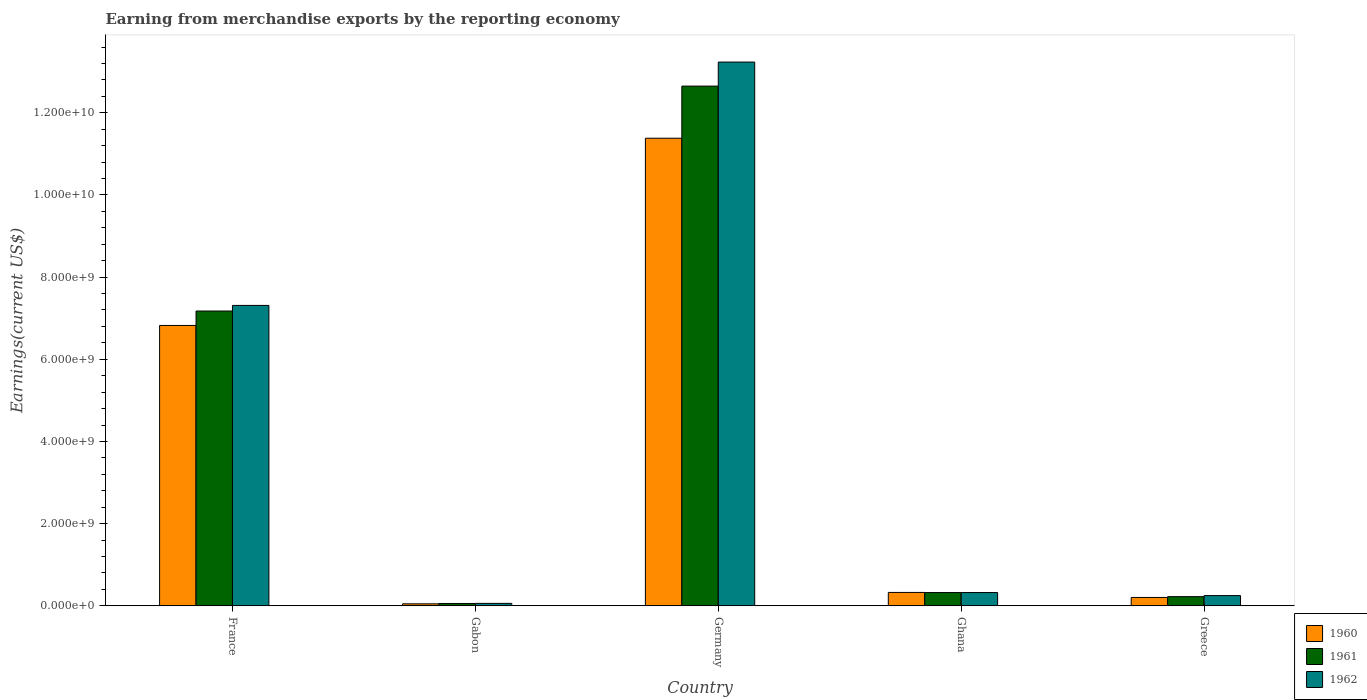How many groups of bars are there?
Provide a short and direct response. 5. How many bars are there on the 4th tick from the left?
Your response must be concise. 3. In how many cases, is the number of bars for a given country not equal to the number of legend labels?
Provide a succinct answer. 0. What is the amount earned from merchandise exports in 1962 in Ghana?
Provide a succinct answer. 3.23e+08. Across all countries, what is the maximum amount earned from merchandise exports in 1962?
Ensure brevity in your answer.  1.32e+1. Across all countries, what is the minimum amount earned from merchandise exports in 1960?
Give a very brief answer. 4.78e+07. In which country was the amount earned from merchandise exports in 1962 minimum?
Provide a succinct answer. Gabon. What is the total amount earned from merchandise exports in 1962 in the graph?
Ensure brevity in your answer.  2.12e+1. What is the difference between the amount earned from merchandise exports in 1961 in France and that in Germany?
Give a very brief answer. -5.48e+09. What is the difference between the amount earned from merchandise exports in 1960 in Germany and the amount earned from merchandise exports in 1961 in Greece?
Provide a succinct answer. 1.12e+1. What is the average amount earned from merchandise exports in 1962 per country?
Your answer should be compact. 4.24e+09. What is the difference between the amount earned from merchandise exports of/in 1962 and amount earned from merchandise exports of/in 1960 in Gabon?
Your answer should be compact. 1.08e+07. What is the ratio of the amount earned from merchandise exports in 1960 in France to that in Gabon?
Offer a terse response. 142.76. What is the difference between the highest and the second highest amount earned from merchandise exports in 1960?
Ensure brevity in your answer.  1.11e+1. What is the difference between the highest and the lowest amount earned from merchandise exports in 1960?
Make the answer very short. 1.13e+1. In how many countries, is the amount earned from merchandise exports in 1962 greater than the average amount earned from merchandise exports in 1962 taken over all countries?
Give a very brief answer. 2. Is the sum of the amount earned from merchandise exports in 1960 in Gabon and Ghana greater than the maximum amount earned from merchandise exports in 1961 across all countries?
Make the answer very short. No. Is it the case that in every country, the sum of the amount earned from merchandise exports in 1962 and amount earned from merchandise exports in 1961 is greater than the amount earned from merchandise exports in 1960?
Offer a very short reply. Yes. Are all the bars in the graph horizontal?
Your response must be concise. No. What is the difference between two consecutive major ticks on the Y-axis?
Give a very brief answer. 2.00e+09. Are the values on the major ticks of Y-axis written in scientific E-notation?
Make the answer very short. Yes. How are the legend labels stacked?
Make the answer very short. Vertical. What is the title of the graph?
Your answer should be very brief. Earning from merchandise exports by the reporting economy. What is the label or title of the X-axis?
Ensure brevity in your answer.  Country. What is the label or title of the Y-axis?
Your response must be concise. Earnings(current US$). What is the Earnings(current US$) in 1960 in France?
Offer a very short reply. 6.82e+09. What is the Earnings(current US$) in 1961 in France?
Give a very brief answer. 7.17e+09. What is the Earnings(current US$) of 1962 in France?
Provide a short and direct response. 7.31e+09. What is the Earnings(current US$) of 1960 in Gabon?
Offer a terse response. 4.78e+07. What is the Earnings(current US$) in 1961 in Gabon?
Your answer should be compact. 5.52e+07. What is the Earnings(current US$) in 1962 in Gabon?
Give a very brief answer. 5.86e+07. What is the Earnings(current US$) in 1960 in Germany?
Offer a terse response. 1.14e+1. What is the Earnings(current US$) of 1961 in Germany?
Keep it short and to the point. 1.26e+1. What is the Earnings(current US$) of 1962 in Germany?
Provide a succinct answer. 1.32e+1. What is the Earnings(current US$) in 1960 in Ghana?
Provide a short and direct response. 3.25e+08. What is the Earnings(current US$) of 1961 in Ghana?
Your answer should be compact. 3.22e+08. What is the Earnings(current US$) in 1962 in Ghana?
Offer a very short reply. 3.23e+08. What is the Earnings(current US$) of 1960 in Greece?
Provide a short and direct response. 2.03e+08. What is the Earnings(current US$) of 1961 in Greece?
Your answer should be compact. 2.22e+08. What is the Earnings(current US$) in 1962 in Greece?
Give a very brief answer. 2.48e+08. Across all countries, what is the maximum Earnings(current US$) of 1960?
Keep it short and to the point. 1.14e+1. Across all countries, what is the maximum Earnings(current US$) in 1961?
Your response must be concise. 1.26e+1. Across all countries, what is the maximum Earnings(current US$) in 1962?
Make the answer very short. 1.32e+1. Across all countries, what is the minimum Earnings(current US$) of 1960?
Offer a terse response. 4.78e+07. Across all countries, what is the minimum Earnings(current US$) in 1961?
Keep it short and to the point. 5.52e+07. Across all countries, what is the minimum Earnings(current US$) of 1962?
Offer a terse response. 5.86e+07. What is the total Earnings(current US$) in 1960 in the graph?
Offer a very short reply. 1.88e+1. What is the total Earnings(current US$) in 1961 in the graph?
Make the answer very short. 2.04e+1. What is the total Earnings(current US$) of 1962 in the graph?
Your answer should be compact. 2.12e+1. What is the difference between the Earnings(current US$) in 1960 in France and that in Gabon?
Offer a terse response. 6.78e+09. What is the difference between the Earnings(current US$) in 1961 in France and that in Gabon?
Offer a terse response. 7.12e+09. What is the difference between the Earnings(current US$) of 1962 in France and that in Gabon?
Your answer should be very brief. 7.25e+09. What is the difference between the Earnings(current US$) of 1960 in France and that in Germany?
Offer a terse response. -4.56e+09. What is the difference between the Earnings(current US$) of 1961 in France and that in Germany?
Provide a short and direct response. -5.48e+09. What is the difference between the Earnings(current US$) in 1962 in France and that in Germany?
Provide a succinct answer. -5.92e+09. What is the difference between the Earnings(current US$) in 1960 in France and that in Ghana?
Your response must be concise. 6.50e+09. What is the difference between the Earnings(current US$) of 1961 in France and that in Ghana?
Provide a succinct answer. 6.85e+09. What is the difference between the Earnings(current US$) in 1962 in France and that in Ghana?
Your response must be concise. 6.99e+09. What is the difference between the Earnings(current US$) of 1960 in France and that in Greece?
Provide a succinct answer. 6.62e+09. What is the difference between the Earnings(current US$) in 1961 in France and that in Greece?
Keep it short and to the point. 6.95e+09. What is the difference between the Earnings(current US$) of 1962 in France and that in Greece?
Provide a succinct answer. 7.06e+09. What is the difference between the Earnings(current US$) of 1960 in Gabon and that in Germany?
Make the answer very short. -1.13e+1. What is the difference between the Earnings(current US$) of 1961 in Gabon and that in Germany?
Offer a very short reply. -1.26e+1. What is the difference between the Earnings(current US$) in 1962 in Gabon and that in Germany?
Offer a very short reply. -1.32e+1. What is the difference between the Earnings(current US$) of 1960 in Gabon and that in Ghana?
Give a very brief answer. -2.77e+08. What is the difference between the Earnings(current US$) of 1961 in Gabon and that in Ghana?
Offer a terse response. -2.67e+08. What is the difference between the Earnings(current US$) in 1962 in Gabon and that in Ghana?
Your answer should be very brief. -2.64e+08. What is the difference between the Earnings(current US$) in 1960 in Gabon and that in Greece?
Keep it short and to the point. -1.55e+08. What is the difference between the Earnings(current US$) of 1961 in Gabon and that in Greece?
Provide a succinct answer. -1.67e+08. What is the difference between the Earnings(current US$) in 1962 in Gabon and that in Greece?
Keep it short and to the point. -1.90e+08. What is the difference between the Earnings(current US$) in 1960 in Germany and that in Ghana?
Keep it short and to the point. 1.11e+1. What is the difference between the Earnings(current US$) of 1961 in Germany and that in Ghana?
Provide a succinct answer. 1.23e+1. What is the difference between the Earnings(current US$) in 1962 in Germany and that in Ghana?
Offer a very short reply. 1.29e+1. What is the difference between the Earnings(current US$) of 1960 in Germany and that in Greece?
Your answer should be very brief. 1.12e+1. What is the difference between the Earnings(current US$) in 1961 in Germany and that in Greece?
Provide a short and direct response. 1.24e+1. What is the difference between the Earnings(current US$) of 1962 in Germany and that in Greece?
Provide a succinct answer. 1.30e+1. What is the difference between the Earnings(current US$) in 1960 in Ghana and that in Greece?
Provide a succinct answer. 1.22e+08. What is the difference between the Earnings(current US$) of 1961 in Ghana and that in Greece?
Make the answer very short. 9.98e+07. What is the difference between the Earnings(current US$) in 1962 in Ghana and that in Greece?
Offer a terse response. 7.43e+07. What is the difference between the Earnings(current US$) in 1960 in France and the Earnings(current US$) in 1961 in Gabon?
Make the answer very short. 6.77e+09. What is the difference between the Earnings(current US$) of 1960 in France and the Earnings(current US$) of 1962 in Gabon?
Provide a short and direct response. 6.77e+09. What is the difference between the Earnings(current US$) in 1961 in France and the Earnings(current US$) in 1962 in Gabon?
Offer a terse response. 7.12e+09. What is the difference between the Earnings(current US$) of 1960 in France and the Earnings(current US$) of 1961 in Germany?
Offer a very short reply. -5.83e+09. What is the difference between the Earnings(current US$) in 1960 in France and the Earnings(current US$) in 1962 in Germany?
Keep it short and to the point. -6.41e+09. What is the difference between the Earnings(current US$) of 1961 in France and the Earnings(current US$) of 1962 in Germany?
Your response must be concise. -6.06e+09. What is the difference between the Earnings(current US$) of 1960 in France and the Earnings(current US$) of 1961 in Ghana?
Provide a succinct answer. 6.50e+09. What is the difference between the Earnings(current US$) in 1960 in France and the Earnings(current US$) in 1962 in Ghana?
Offer a very short reply. 6.50e+09. What is the difference between the Earnings(current US$) of 1961 in France and the Earnings(current US$) of 1962 in Ghana?
Provide a short and direct response. 6.85e+09. What is the difference between the Earnings(current US$) of 1960 in France and the Earnings(current US$) of 1961 in Greece?
Your response must be concise. 6.60e+09. What is the difference between the Earnings(current US$) of 1960 in France and the Earnings(current US$) of 1962 in Greece?
Make the answer very short. 6.58e+09. What is the difference between the Earnings(current US$) of 1961 in France and the Earnings(current US$) of 1962 in Greece?
Your answer should be very brief. 6.93e+09. What is the difference between the Earnings(current US$) of 1960 in Gabon and the Earnings(current US$) of 1961 in Germany?
Offer a very short reply. -1.26e+1. What is the difference between the Earnings(current US$) in 1960 in Gabon and the Earnings(current US$) in 1962 in Germany?
Your response must be concise. -1.32e+1. What is the difference between the Earnings(current US$) in 1961 in Gabon and the Earnings(current US$) in 1962 in Germany?
Provide a short and direct response. -1.32e+1. What is the difference between the Earnings(current US$) of 1960 in Gabon and the Earnings(current US$) of 1961 in Ghana?
Offer a terse response. -2.74e+08. What is the difference between the Earnings(current US$) of 1960 in Gabon and the Earnings(current US$) of 1962 in Ghana?
Your response must be concise. -2.75e+08. What is the difference between the Earnings(current US$) of 1961 in Gabon and the Earnings(current US$) of 1962 in Ghana?
Ensure brevity in your answer.  -2.67e+08. What is the difference between the Earnings(current US$) in 1960 in Gabon and the Earnings(current US$) in 1961 in Greece?
Make the answer very short. -1.75e+08. What is the difference between the Earnings(current US$) of 1960 in Gabon and the Earnings(current US$) of 1962 in Greece?
Provide a succinct answer. -2.00e+08. What is the difference between the Earnings(current US$) in 1961 in Gabon and the Earnings(current US$) in 1962 in Greece?
Offer a very short reply. -1.93e+08. What is the difference between the Earnings(current US$) in 1960 in Germany and the Earnings(current US$) in 1961 in Ghana?
Your answer should be compact. 1.11e+1. What is the difference between the Earnings(current US$) in 1960 in Germany and the Earnings(current US$) in 1962 in Ghana?
Your answer should be compact. 1.11e+1. What is the difference between the Earnings(current US$) of 1961 in Germany and the Earnings(current US$) of 1962 in Ghana?
Ensure brevity in your answer.  1.23e+1. What is the difference between the Earnings(current US$) in 1960 in Germany and the Earnings(current US$) in 1961 in Greece?
Keep it short and to the point. 1.12e+1. What is the difference between the Earnings(current US$) of 1960 in Germany and the Earnings(current US$) of 1962 in Greece?
Keep it short and to the point. 1.11e+1. What is the difference between the Earnings(current US$) of 1961 in Germany and the Earnings(current US$) of 1962 in Greece?
Ensure brevity in your answer.  1.24e+1. What is the difference between the Earnings(current US$) in 1960 in Ghana and the Earnings(current US$) in 1961 in Greece?
Your response must be concise. 1.03e+08. What is the difference between the Earnings(current US$) in 1960 in Ghana and the Earnings(current US$) in 1962 in Greece?
Provide a succinct answer. 7.69e+07. What is the difference between the Earnings(current US$) in 1961 in Ghana and the Earnings(current US$) in 1962 in Greece?
Offer a very short reply. 7.40e+07. What is the average Earnings(current US$) in 1960 per country?
Your answer should be very brief. 3.76e+09. What is the average Earnings(current US$) of 1961 per country?
Give a very brief answer. 4.08e+09. What is the average Earnings(current US$) of 1962 per country?
Offer a very short reply. 4.24e+09. What is the difference between the Earnings(current US$) in 1960 and Earnings(current US$) in 1961 in France?
Your response must be concise. -3.51e+08. What is the difference between the Earnings(current US$) of 1960 and Earnings(current US$) of 1962 in France?
Offer a very short reply. -4.87e+08. What is the difference between the Earnings(current US$) of 1961 and Earnings(current US$) of 1962 in France?
Provide a succinct answer. -1.37e+08. What is the difference between the Earnings(current US$) in 1960 and Earnings(current US$) in 1961 in Gabon?
Your answer should be very brief. -7.40e+06. What is the difference between the Earnings(current US$) of 1960 and Earnings(current US$) of 1962 in Gabon?
Ensure brevity in your answer.  -1.08e+07. What is the difference between the Earnings(current US$) of 1961 and Earnings(current US$) of 1962 in Gabon?
Offer a terse response. -3.40e+06. What is the difference between the Earnings(current US$) of 1960 and Earnings(current US$) of 1961 in Germany?
Provide a succinct answer. -1.27e+09. What is the difference between the Earnings(current US$) of 1960 and Earnings(current US$) of 1962 in Germany?
Offer a very short reply. -1.85e+09. What is the difference between the Earnings(current US$) in 1961 and Earnings(current US$) in 1962 in Germany?
Keep it short and to the point. -5.85e+08. What is the difference between the Earnings(current US$) of 1960 and Earnings(current US$) of 1961 in Ghana?
Ensure brevity in your answer.  2.90e+06. What is the difference between the Earnings(current US$) of 1960 and Earnings(current US$) of 1962 in Ghana?
Your answer should be very brief. 2.60e+06. What is the difference between the Earnings(current US$) of 1960 and Earnings(current US$) of 1961 in Greece?
Ensure brevity in your answer.  -1.94e+07. What is the difference between the Earnings(current US$) in 1960 and Earnings(current US$) in 1962 in Greece?
Provide a succinct answer. -4.52e+07. What is the difference between the Earnings(current US$) of 1961 and Earnings(current US$) of 1962 in Greece?
Provide a short and direct response. -2.58e+07. What is the ratio of the Earnings(current US$) in 1960 in France to that in Gabon?
Your response must be concise. 142.76. What is the ratio of the Earnings(current US$) of 1961 in France to that in Gabon?
Offer a terse response. 129.98. What is the ratio of the Earnings(current US$) in 1962 in France to that in Gabon?
Give a very brief answer. 124.77. What is the ratio of the Earnings(current US$) of 1960 in France to that in Germany?
Keep it short and to the point. 0.6. What is the ratio of the Earnings(current US$) in 1961 in France to that in Germany?
Your response must be concise. 0.57. What is the ratio of the Earnings(current US$) of 1962 in France to that in Germany?
Offer a very short reply. 0.55. What is the ratio of the Earnings(current US$) in 1960 in France to that in Ghana?
Give a very brief answer. 20.98. What is the ratio of the Earnings(current US$) in 1961 in France to that in Ghana?
Provide a succinct answer. 22.26. What is the ratio of the Earnings(current US$) in 1962 in France to that in Ghana?
Provide a succinct answer. 22.66. What is the ratio of the Earnings(current US$) of 1960 in France to that in Greece?
Make the answer very short. 33.6. What is the ratio of the Earnings(current US$) in 1961 in France to that in Greece?
Offer a very short reply. 32.25. What is the ratio of the Earnings(current US$) in 1962 in France to that in Greece?
Your response must be concise. 29.45. What is the ratio of the Earnings(current US$) of 1960 in Gabon to that in Germany?
Keep it short and to the point. 0. What is the ratio of the Earnings(current US$) in 1961 in Gabon to that in Germany?
Offer a very short reply. 0. What is the ratio of the Earnings(current US$) in 1962 in Gabon to that in Germany?
Your response must be concise. 0. What is the ratio of the Earnings(current US$) of 1960 in Gabon to that in Ghana?
Offer a very short reply. 0.15. What is the ratio of the Earnings(current US$) of 1961 in Gabon to that in Ghana?
Provide a succinct answer. 0.17. What is the ratio of the Earnings(current US$) in 1962 in Gabon to that in Ghana?
Make the answer very short. 0.18. What is the ratio of the Earnings(current US$) in 1960 in Gabon to that in Greece?
Ensure brevity in your answer.  0.24. What is the ratio of the Earnings(current US$) in 1961 in Gabon to that in Greece?
Your answer should be very brief. 0.25. What is the ratio of the Earnings(current US$) of 1962 in Gabon to that in Greece?
Your answer should be compact. 0.24. What is the ratio of the Earnings(current US$) of 1960 in Germany to that in Ghana?
Offer a terse response. 35. What is the ratio of the Earnings(current US$) of 1961 in Germany to that in Ghana?
Provide a short and direct response. 39.25. What is the ratio of the Earnings(current US$) of 1962 in Germany to that in Ghana?
Your answer should be compact. 41.03. What is the ratio of the Earnings(current US$) in 1960 in Germany to that in Greece?
Your answer should be very brief. 56.04. What is the ratio of the Earnings(current US$) in 1961 in Germany to that in Greece?
Offer a terse response. 56.85. What is the ratio of the Earnings(current US$) of 1962 in Germany to that in Greece?
Your answer should be compact. 53.3. What is the ratio of the Earnings(current US$) of 1960 in Ghana to that in Greece?
Make the answer very short. 1.6. What is the ratio of the Earnings(current US$) in 1961 in Ghana to that in Greece?
Offer a very short reply. 1.45. What is the ratio of the Earnings(current US$) in 1962 in Ghana to that in Greece?
Offer a terse response. 1.3. What is the difference between the highest and the second highest Earnings(current US$) in 1960?
Make the answer very short. 4.56e+09. What is the difference between the highest and the second highest Earnings(current US$) of 1961?
Your response must be concise. 5.48e+09. What is the difference between the highest and the second highest Earnings(current US$) in 1962?
Ensure brevity in your answer.  5.92e+09. What is the difference between the highest and the lowest Earnings(current US$) in 1960?
Ensure brevity in your answer.  1.13e+1. What is the difference between the highest and the lowest Earnings(current US$) of 1961?
Offer a terse response. 1.26e+1. What is the difference between the highest and the lowest Earnings(current US$) in 1962?
Your answer should be compact. 1.32e+1. 